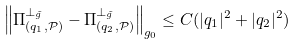Convert formula to latex. <formula><loc_0><loc_0><loc_500><loc_500>\left \| \Pi _ { ( q _ { 1 } , \mathcal { P } ) } ^ { \bot _ { \tilde { g } } } - \Pi _ { ( q _ { 2 } , \mathcal { P } ) } ^ { \bot _ { \tilde { g } } } \right \| _ { g _ { 0 } } \leq C ( | q _ { 1 } | ^ { 2 } + | q _ { 2 } | ^ { 2 } )</formula> 